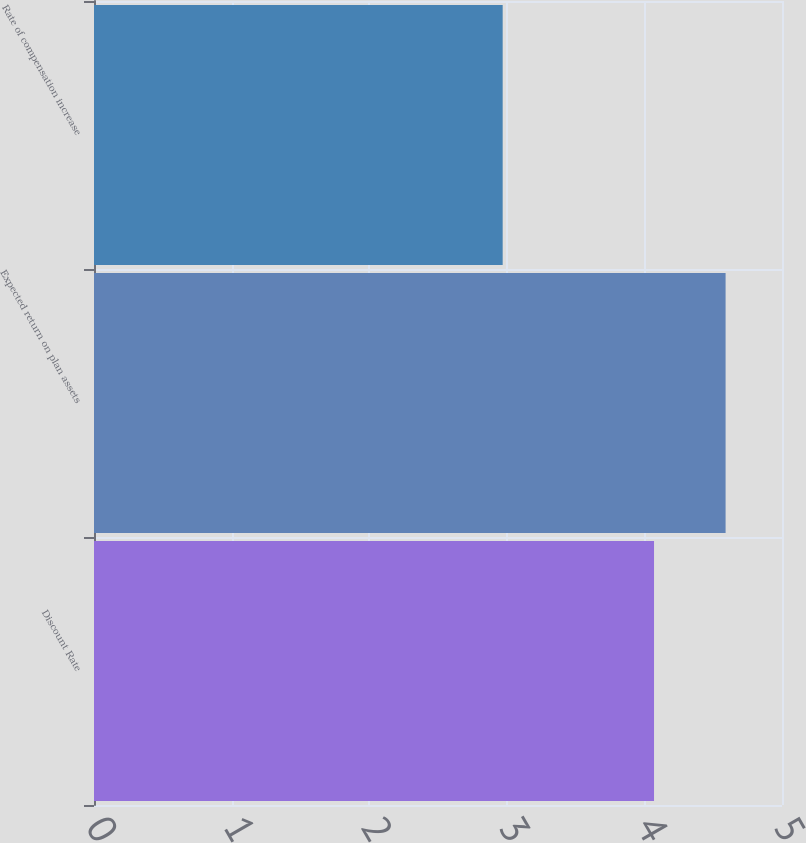<chart> <loc_0><loc_0><loc_500><loc_500><bar_chart><fcel>Discount Rate<fcel>Expected return on plan assets<fcel>Rate of compensation increase<nl><fcel>4.07<fcel>4.59<fcel>2.97<nl></chart> 